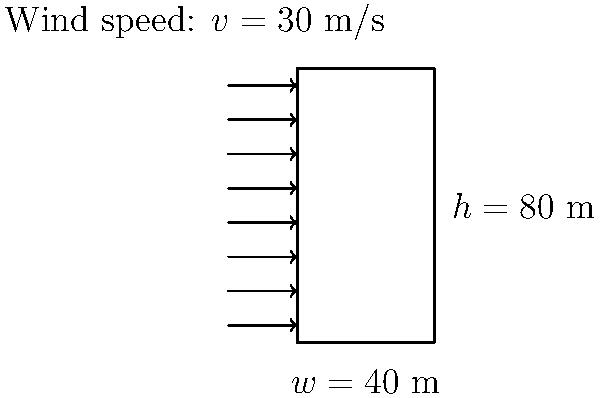As an auto repair shop owner specializing in electric and hybrid vehicles, you're considering expanding your business to include a tall service center. Calculate the total wind load on the front face of the proposed building using the given dimensions and wind speed. Assume the drag coefficient $C_d = 1.4$ and air density $\rho = 1.225$ kg/m³. To calculate the wind load on the building, we'll use the following steps:

1. Identify the given information:
   - Building height $(h) = 80$ m
   - Building width $(w) = 40$ m
   - Wind speed $(v) = 30$ m/s
   - Drag coefficient $(C_d) = 1.4$
   - Air density $(\rho) = 1.225$ kg/m³

2. Calculate the frontal area $(A)$ of the building:
   $A = h \times w = 80 \text{ m} \times 40 \text{ m} = 3200 \text{ m}^2$

3. Use the wind load formula:
   $F = \frac{1}{2} \times \rho \times v^2 \times C_d \times A$

4. Substitute the values into the formula:
   $F = \frac{1}{2} \times 1.225 \text{ kg/m}^3 \times (30 \text{ m/s})^2 \times 1.4 \times 3200 \text{ m}^2$

5. Calculate the result:
   $F = 0.5 \times 1.225 \times 900 \times 1.4 \times 3200$
   $F = 2,462,400 \text{ N}$
   $F \approx 2,462 \text{ kN}$

Therefore, the total wind load on the front face of the building is approximately 2,462 kN.
Answer: 2,462 kN 